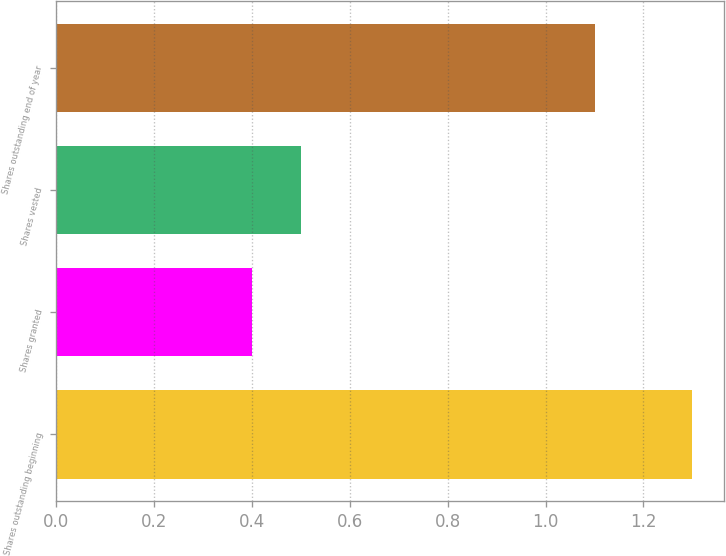<chart> <loc_0><loc_0><loc_500><loc_500><bar_chart><fcel>Shares outstanding beginning<fcel>Shares granted<fcel>Shares vested<fcel>Shares outstanding end of year<nl><fcel>1.3<fcel>0.4<fcel>0.5<fcel>1.1<nl></chart> 